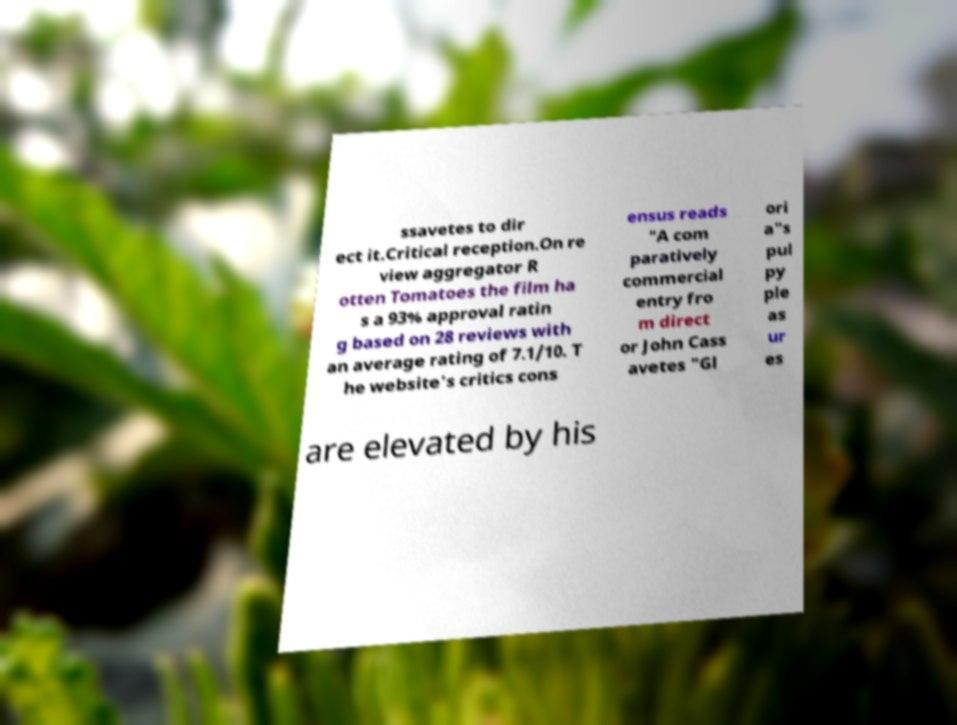Can you read and provide the text displayed in the image?This photo seems to have some interesting text. Can you extract and type it out for me? ssavetes to dir ect it.Critical reception.On re view aggregator R otten Tomatoes the film ha s a 93% approval ratin g based on 28 reviews with an average rating of 7.1/10. T he website's critics cons ensus reads "A com paratively commercial entry fro m direct or John Cass avetes "Gl ori a"s pul py ple as ur es are elevated by his 